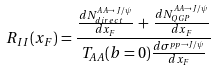<formula> <loc_0><loc_0><loc_500><loc_500>R _ { I I } ( x _ { F } ) = \frac { \frac { d N ^ { A A \rightarrow J / \psi } _ { d i r e c t } } { d x _ { F } } \, + \, \frac { d N ^ { A A \rightarrow J / \psi } _ { Q G P } } { d x _ { F } } } { T _ { A A } ( b = 0 ) \frac { d \sigma ^ { p p \rightarrow J / \psi } } { d x _ { F } } }</formula> 